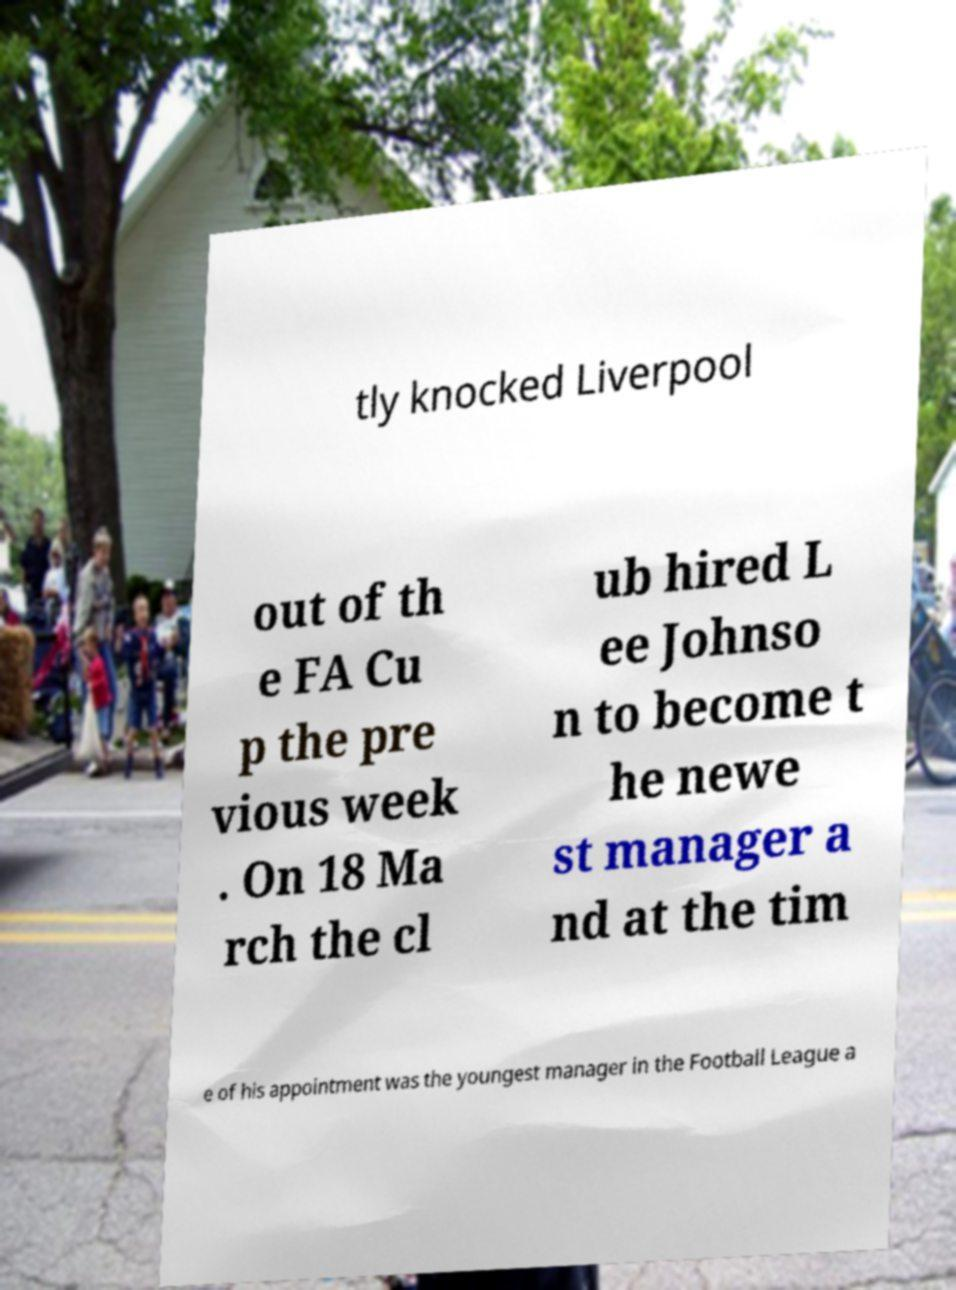There's text embedded in this image that I need extracted. Can you transcribe it verbatim? tly knocked Liverpool out of th e FA Cu p the pre vious week . On 18 Ma rch the cl ub hired L ee Johnso n to become t he newe st manager a nd at the tim e of his appointment was the youngest manager in the Football League a 